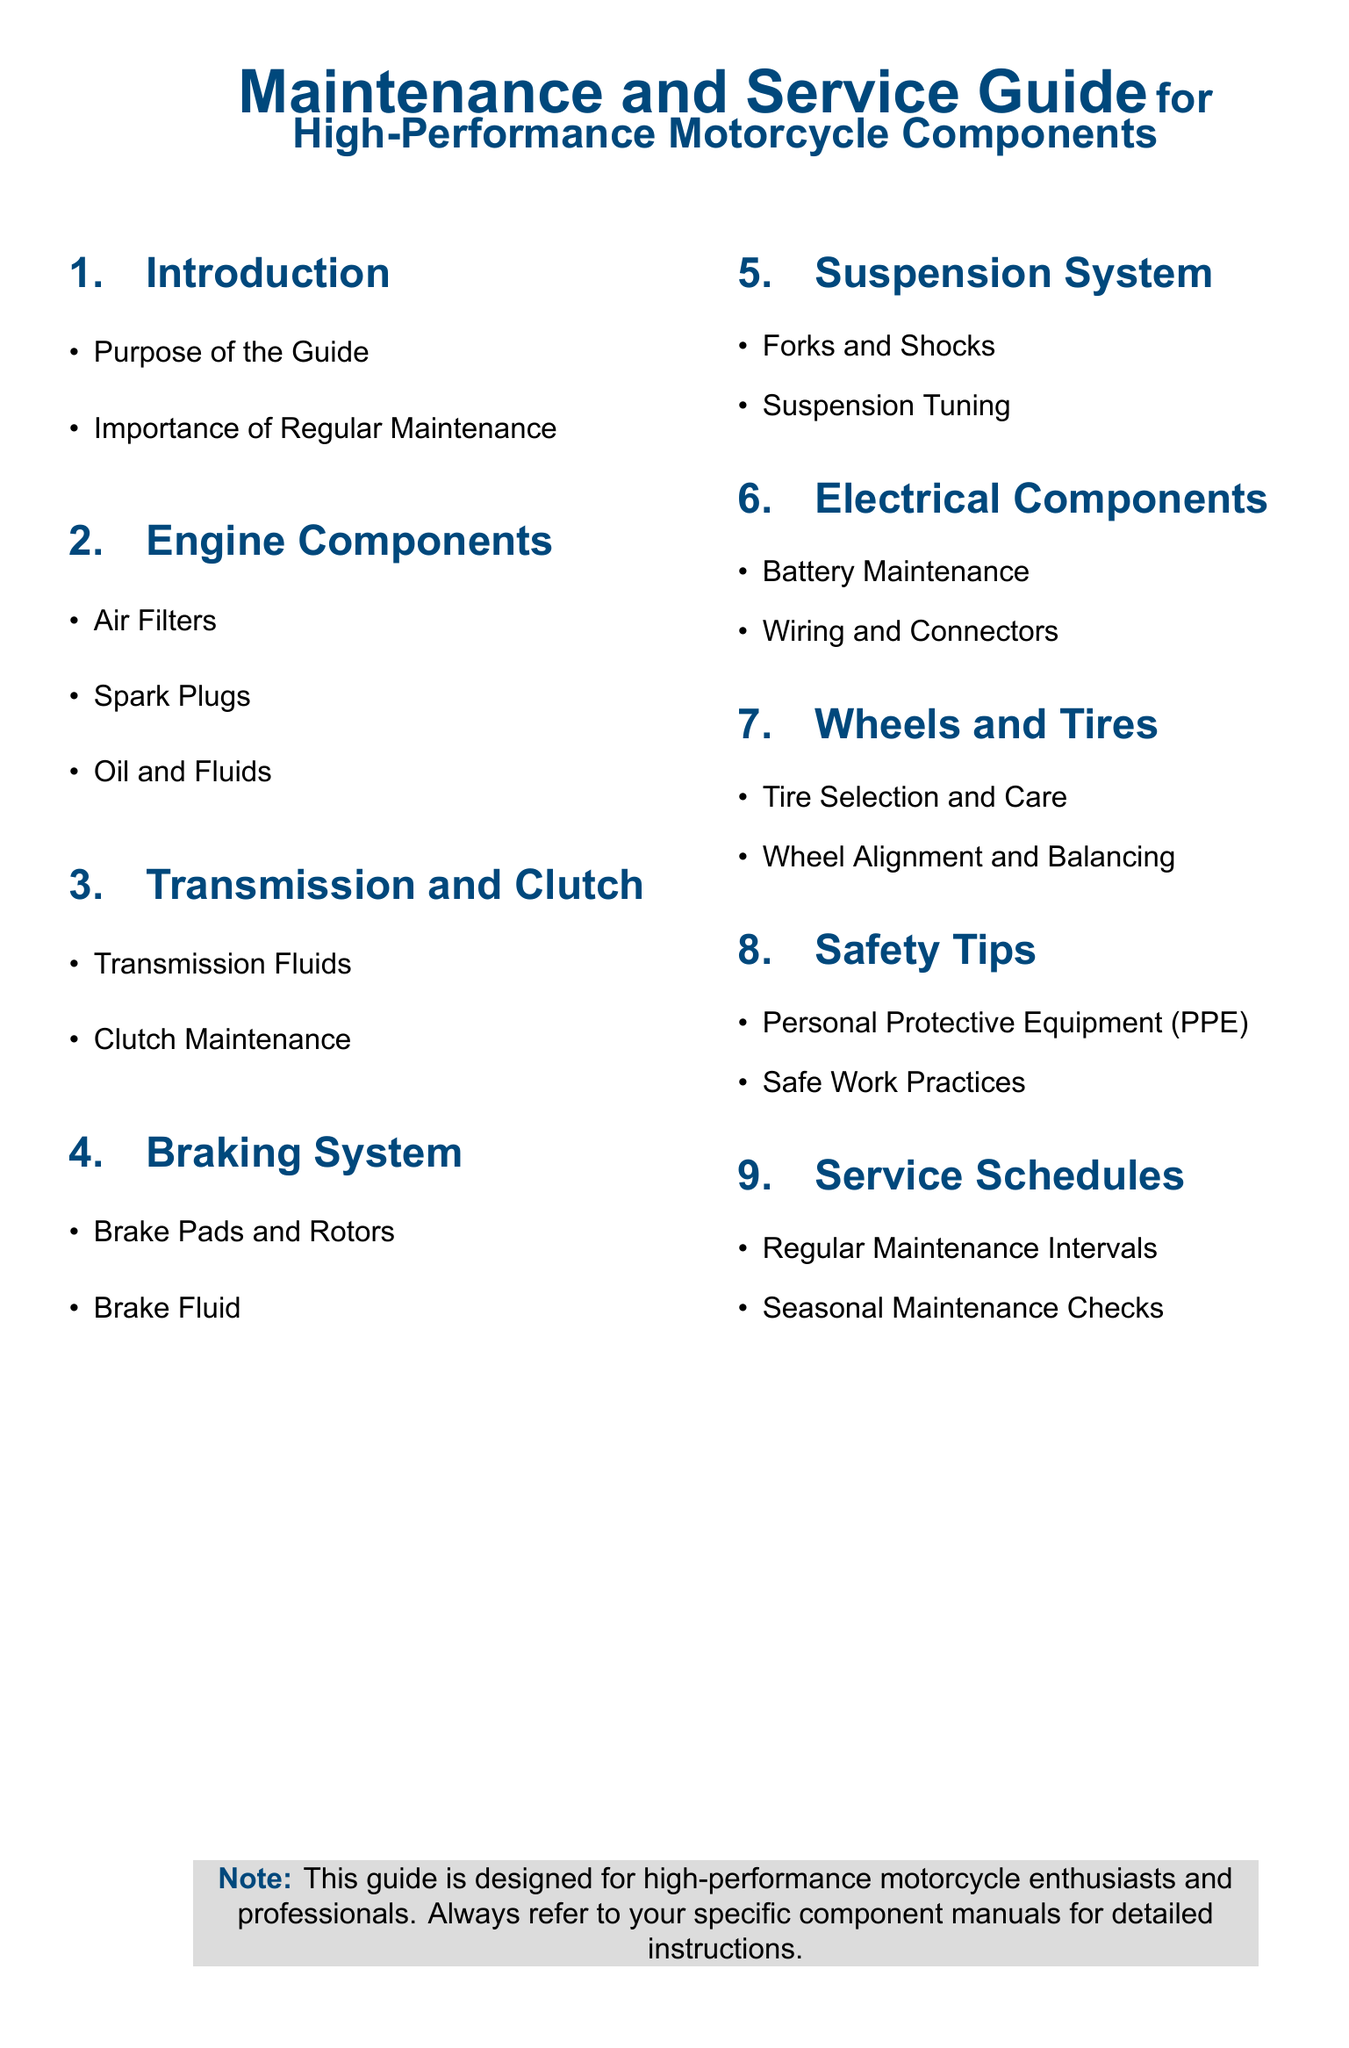What is the purpose of the guide? The purpose of the guide is outlined in the section on Introduction, focusing on providing maintenance and service information.
Answer: Purpose of the Guide How often should regular maintenance be performed? This is discussed in the Service Schedules section, where regular maintenance intervals are mentioned.
Answer: Regular Maintenance Intervals What components are listed under Engine Components? The Engine Components section lists specific items that require maintenance.
Answer: Air Filters, Spark Plugs, Oil and Fluids What type of fluids are emphasized in the Transmission and Clutch section? The Transmission and Clutch section specifies the types of fluids that are crucial for performance.
Answer: Transmission Fluids What protective gear is recommended for safety? The Safety Tips section advises on essential equipment for safe maintenance work.
Answer: Personal Protective Equipment (PPE) Name one aspect of the Braking System covered in the guide. The Braking System section identifies key components that need maintenance checks or replacements.
Answer: Brake Pads and Rotors What is mentioned regarding battery maintenance? The Electrical Components section addresses specific maintenance tasks for the battery.
Answer: Battery Maintenance What is the significance of seasonal maintenance checks? The Service Schedules section highlights the importance of adapting maintenance based on seasonal changes.
Answer: Seasonal Maintenance Checks What color is used for the section titles? The document specifies the color used for section titles to enhance clarity and visual appeal.
Answer: Motorblue 